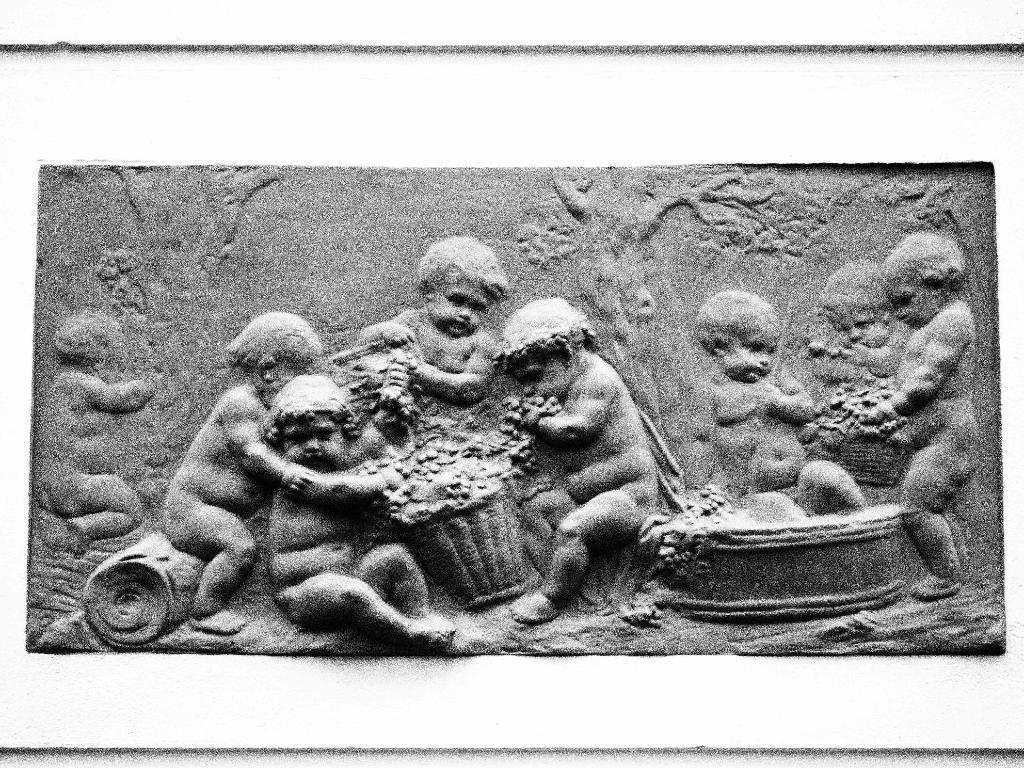What is the color scheme of the image? The image is black and white. What can be seen on the wall in the image? There is a picture of a sculpture on a wall in the image. What is the name of the sculpture in the image? There is no information provided about the name of the sculpture in the image. Is there a garden visible in the image? There is no mention of a garden in the provided facts, so it cannot be determined if one is present in the image. 